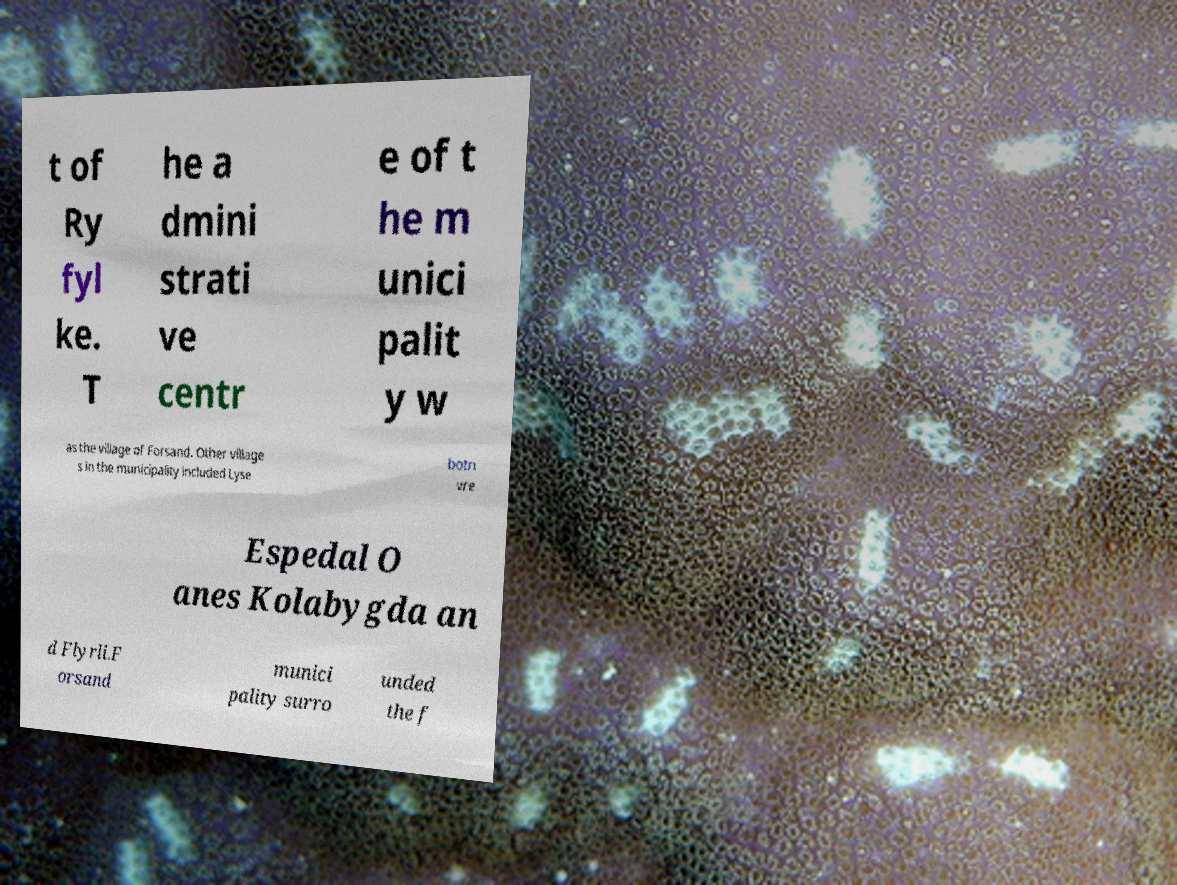For documentation purposes, I need the text within this image transcribed. Could you provide that? t of Ry fyl ke. T he a dmini strati ve centr e of t he m unici palit y w as the village of Forsand. Other village s in the municipality included Lyse botn vre Espedal O anes Kolabygda an d Flyrli.F orsand munici pality surro unded the f 